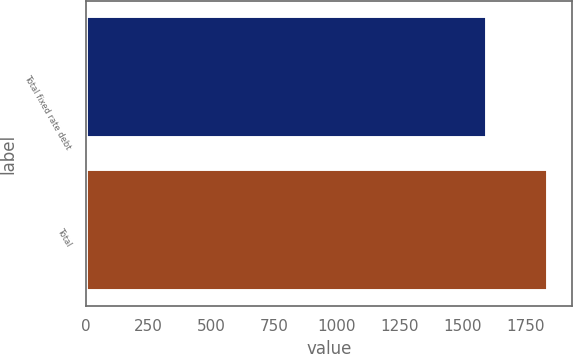<chart> <loc_0><loc_0><loc_500><loc_500><bar_chart><fcel>Total fixed rate debt<fcel>Total<nl><fcel>1599<fcel>1843<nl></chart> 